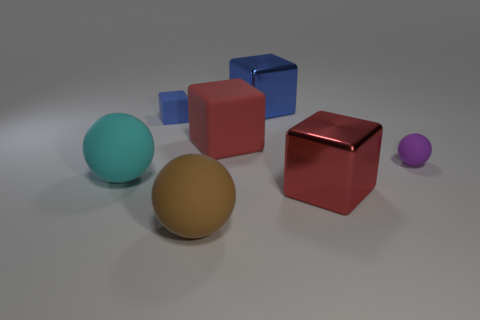The blue metallic thing is what shape?
Offer a terse response. Cube. How many other things have the same shape as the brown thing?
Keep it short and to the point. 2. What number of big objects are behind the large brown thing and on the left side of the large blue metal cube?
Provide a short and direct response. 2. The big rubber block has what color?
Give a very brief answer. Red. Are there any blue things that have the same material as the big brown sphere?
Offer a very short reply. Yes. There is a shiny thing left of the big metallic cube that is on the right side of the blue metallic block; are there any tiny purple rubber spheres behind it?
Keep it short and to the point. No. There is a large blue metallic block; are there any big cyan matte balls behind it?
Your answer should be very brief. No. Is there a big matte thing that has the same color as the small matte block?
Your answer should be compact. No. What number of small objects are either cyan matte objects or blue blocks?
Offer a very short reply. 1. Does the large red cube that is to the right of the big red matte thing have the same material as the cyan thing?
Offer a terse response. No. 